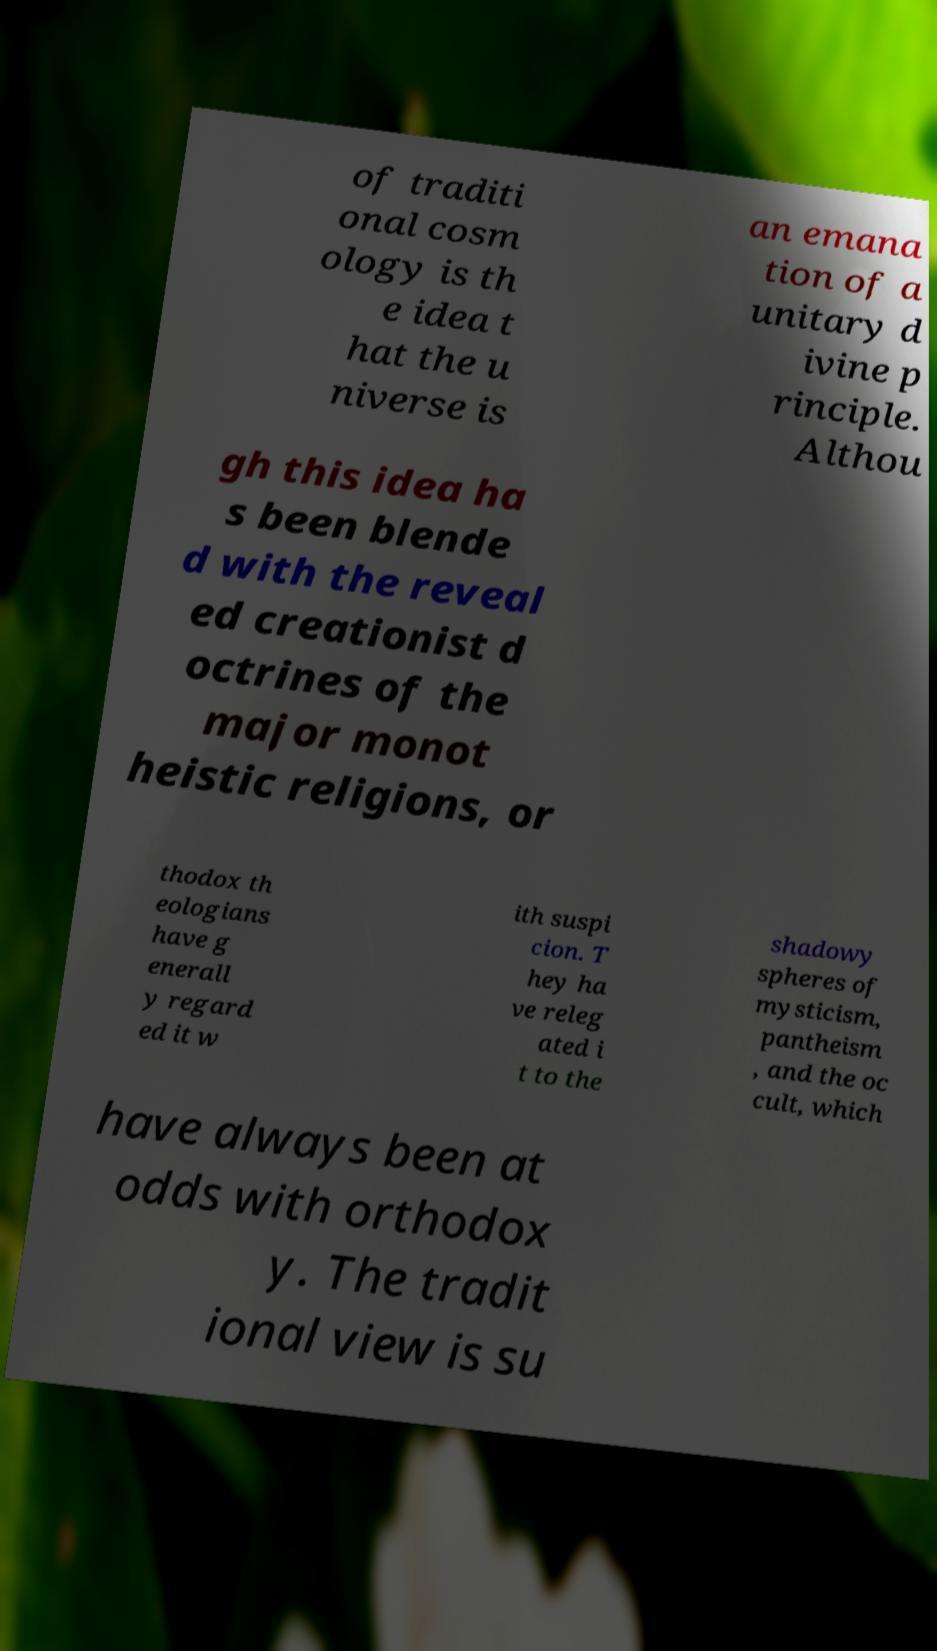Please read and relay the text visible in this image. What does it say? of traditi onal cosm ology is th e idea t hat the u niverse is an emana tion of a unitary d ivine p rinciple. Althou gh this idea ha s been blende d with the reveal ed creationist d octrines of the major monot heistic religions, or thodox th eologians have g enerall y regard ed it w ith suspi cion. T hey ha ve releg ated i t to the shadowy spheres of mysticism, pantheism , and the oc cult, which have always been at odds with orthodox y. The tradit ional view is su 